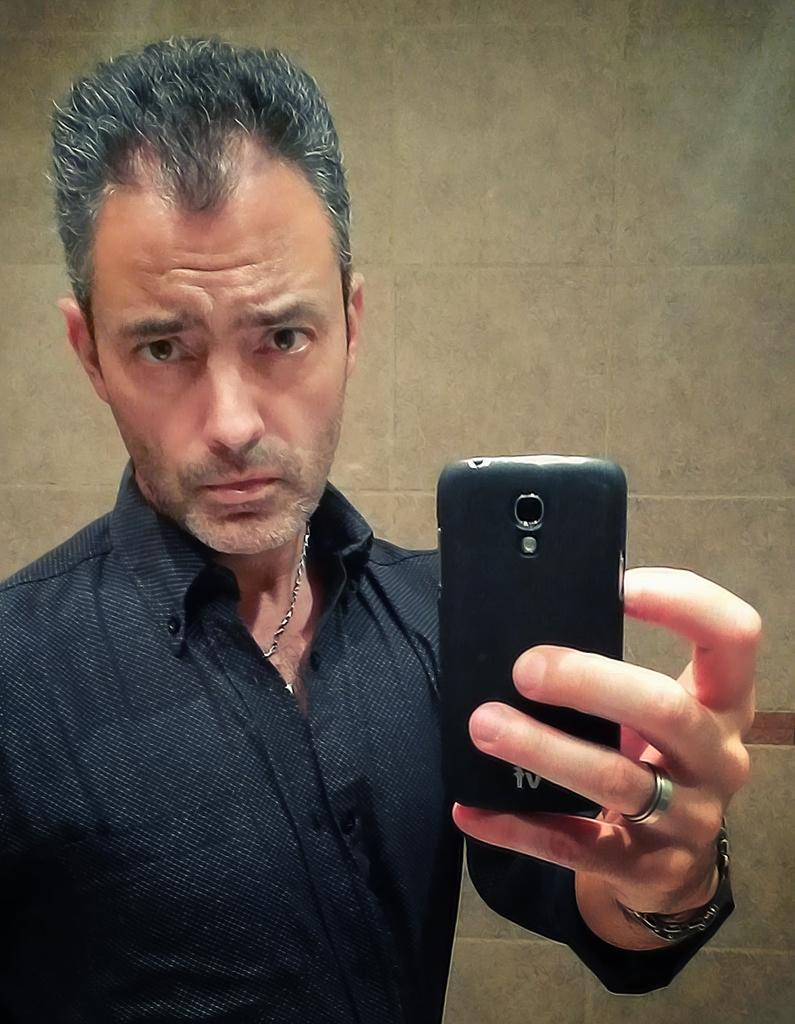Who is present in the image? There is a man in the picture. What is the man doing in the image? The man is taking a photo with his mobile. What can be seen in the background of the picture? There is a wall in the background of the picture. How many kittens are playing with a feather in the image? There are no kittens or feathers present in the image. What riddle can be solved by looking at the image? There is no riddle associated with the image; it simply shows a man taking a photo with his mobile. 